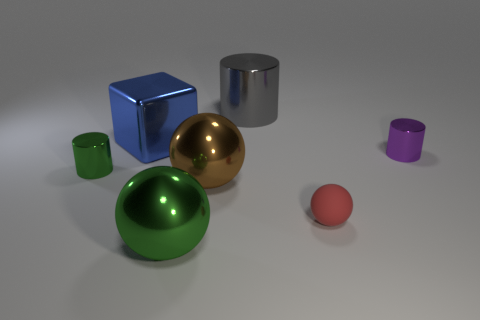Subtract all red rubber balls. How many balls are left? 2 Add 1 big objects. How many objects exist? 8 Subtract 2 balls. How many balls are left? 1 Subtract all red spheres. How many spheres are left? 2 Add 5 brown cubes. How many brown cubes exist? 5 Subtract 0 brown cylinders. How many objects are left? 7 Subtract all blocks. How many objects are left? 6 Subtract all green cylinders. Subtract all gray balls. How many cylinders are left? 2 Subtract all red cylinders. How many yellow spheres are left? 0 Subtract all cubes. Subtract all shiny spheres. How many objects are left? 4 